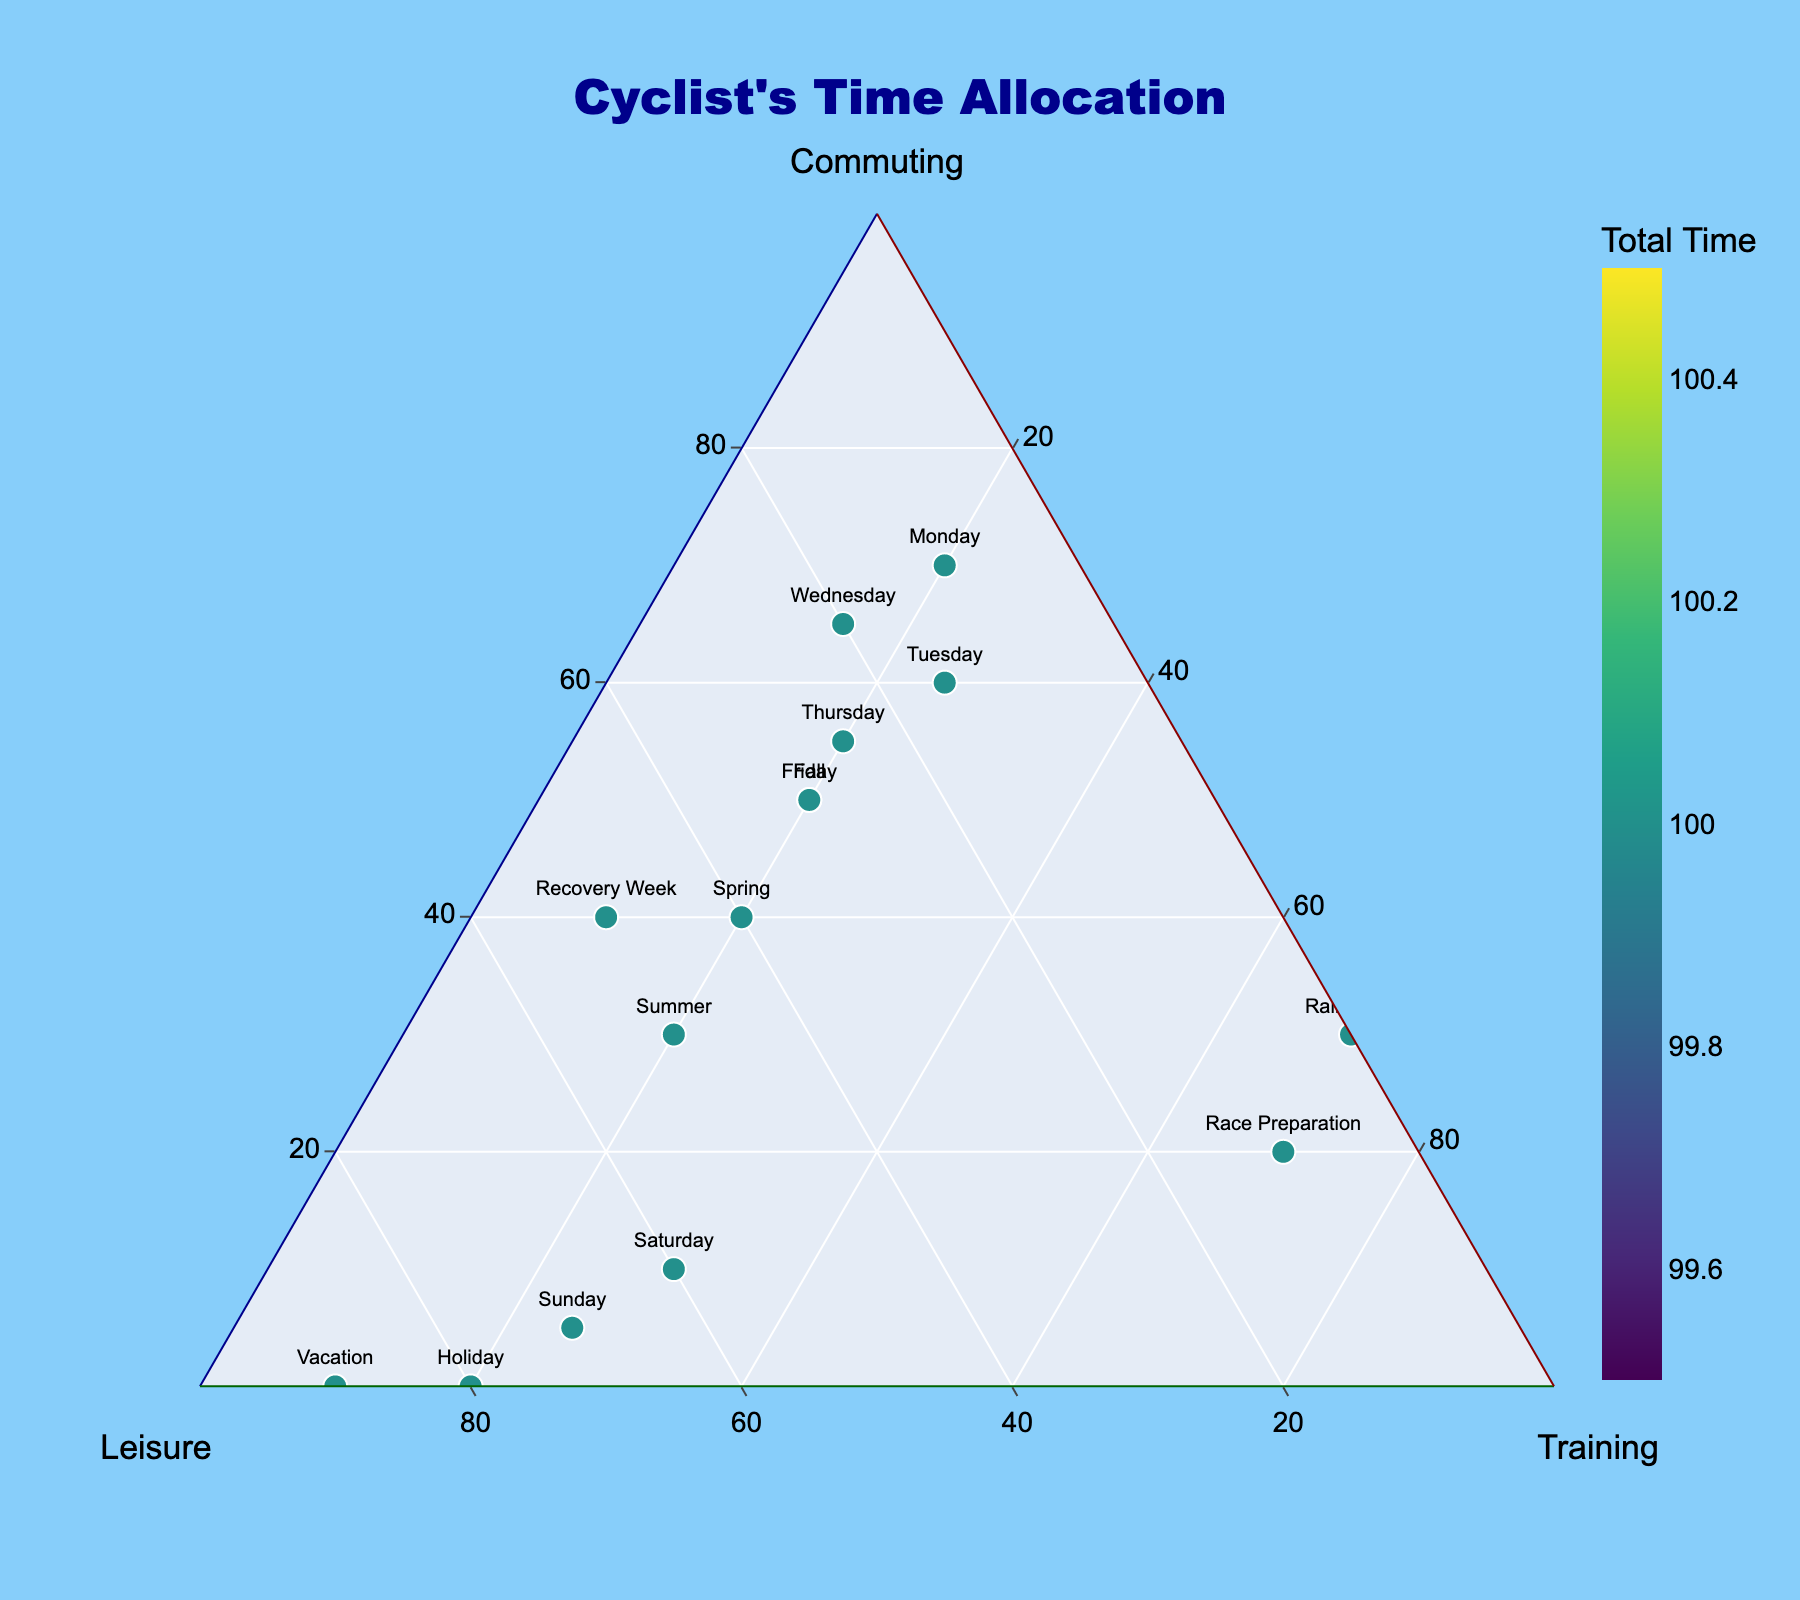How is the cyclist's time allocated between Commuting, Leisure, and Training activities shown? The ternary plot shows the time allocation among Commuting, Leisure, and Training as points within a triangular coordinate system, with each axis representing one of the activities. The position of a point in the triangle reflects the percentage split among these three activities for that day or event. For example, if a point is closer to the "Commuting" axis, it means a larger portion of time on that day is spent on commuting. The color and size of the markers can also provide additional information, such as the total time spent on all activities combined.
Answer: Triangle plot with points What is the title of the figure? The title of the figure is located at the top-center of the plot. It provides an overview or indicates the main focus of the plot. In this case, it specifies that the plot shows time allocation for cycling activities.
Answer: Cyclist's Time Allocation Which day features the highest percentage of leisure time? Locate the point that is closest to the Leisure axis, which means the highest percentage of time is spent on leisure rides on that day. Here, the label "Vacation" is closest to the Leisure axis, indicating the highest percentage.
Answer: Vacation Which day shows the highest training time percentage? Training time percentage is shown along the corresponding axis. The point closest to the Training axis and furthest from the other two axes represents the highest training time percentage. The label "Rainy Day" is closest to the Training axis.
Answer: Rainy Day Which days have an equal percentage split between Commuting, Leisure, and Training? Look for points approximately in the center of the ternary plot triangle, where each axis's value would be roughly one-third of the total. Visually locate these points and check their labels. There is no label exactly on the center, but "Summer" and "Spring" are closer with roughly equal splits.
Answer: None exactly, "Spring" and "Summer" are closest Which day has the lowest total cycling time across all activities? Identify the color gradient on the markers that represents the total time spent on cycling activities. The point with the least intense color (matching the start of the color bar) signifies the least total time. The label "Sunday" has the most subdued color.
Answer: Sunday What type of marker symbols are used in the plot? The marker symbols within the plot are used to denote each data point's place on the ternary plot, identified by their shape. Here, the markers are described as circles.
Answer: Circles Can you determine which day is better for more leisure time compared to commuting? Compare the positions of points relative to the Leisure and Commuting axes for various days. Days like "Sunday," "Holiday," and "Vacation" are positioned closer to the Leisure axis and farther from the Commuting axis, indicating more leisure time compared to commuting.
Answer: Sunday, Holiday, Vacation Compare the commuting percentage between Monday and Friday. Which one is higher? Check the positions of the points labeled "Monday" and "Friday" along the Commuting axis. The point farther from the Commuting axis's origin (closer to the axis) signifies a higher commuting percentage. "Monday" is closer, therefore, it has a higher commuting percentage.
Answer: Monday What can you infer about the training percentages on "Race Preparation" and "Recovery Week"? Locate both points on the ternary plot and compare their distances from the Training axis. "Race Preparation" is much closer to the Training axis than "Recovery Week," indicating a higher training percentage on "Race Preparation" day.
Answer: Higher on Race Preparation 